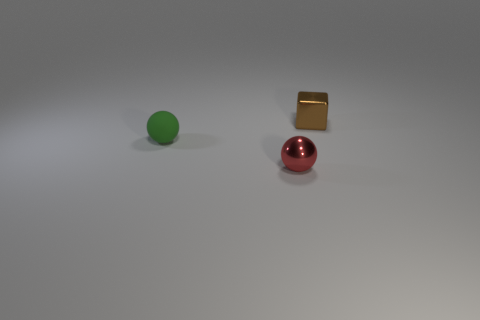Add 2 big gray rubber cylinders. How many objects exist? 5 Subtract all cubes. How many objects are left? 2 Add 3 shiny objects. How many shiny objects exist? 5 Subtract 0 blue cylinders. How many objects are left? 3 Subtract all small brown shiny blocks. Subtract all tiny brown cubes. How many objects are left? 1 Add 2 small blocks. How many small blocks are left? 3 